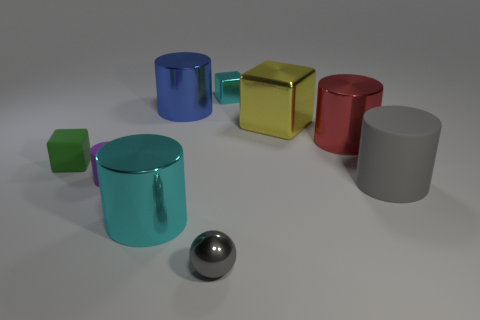Subtract 2 cylinders. How many cylinders are left? 3 Subtract all yellow cylinders. Subtract all gray balls. How many cylinders are left? 5 Add 1 big yellow metallic blocks. How many objects exist? 10 Subtract all blocks. How many objects are left? 6 Subtract all blue metal spheres. Subtract all tiny cyan blocks. How many objects are left? 8 Add 3 big cyan objects. How many big cyan objects are left? 4 Add 5 large red rubber blocks. How many large red rubber blocks exist? 5 Subtract 1 gray cylinders. How many objects are left? 8 